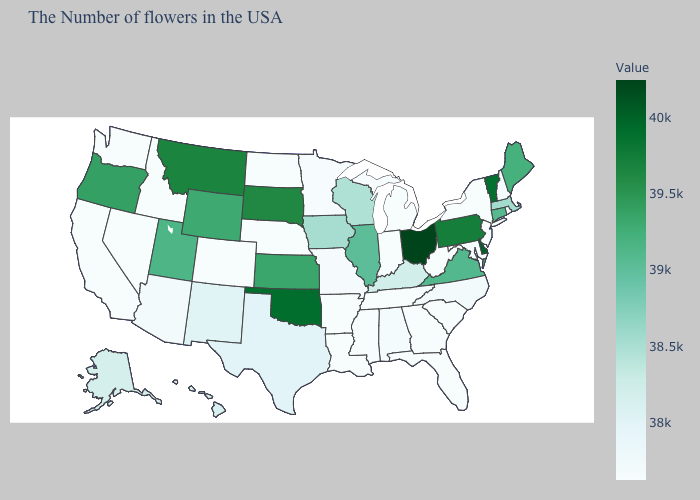Does the map have missing data?
Concise answer only. No. Does New Jersey have the lowest value in the Northeast?
Answer briefly. Yes. Among the states that border Idaho , which have the highest value?
Keep it brief. Montana. 